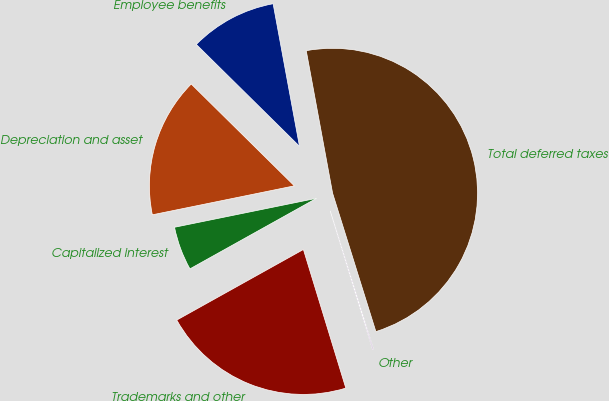Convert chart to OTSL. <chart><loc_0><loc_0><loc_500><loc_500><pie_chart><fcel>Employee benefits<fcel>Depreciation and asset<fcel>Capitalized interest<fcel>Trademarks and other<fcel>Other<fcel>Total deferred taxes<nl><fcel>9.69%<fcel>15.6%<fcel>4.89%<fcel>21.63%<fcel>0.1%<fcel>48.08%<nl></chart> 